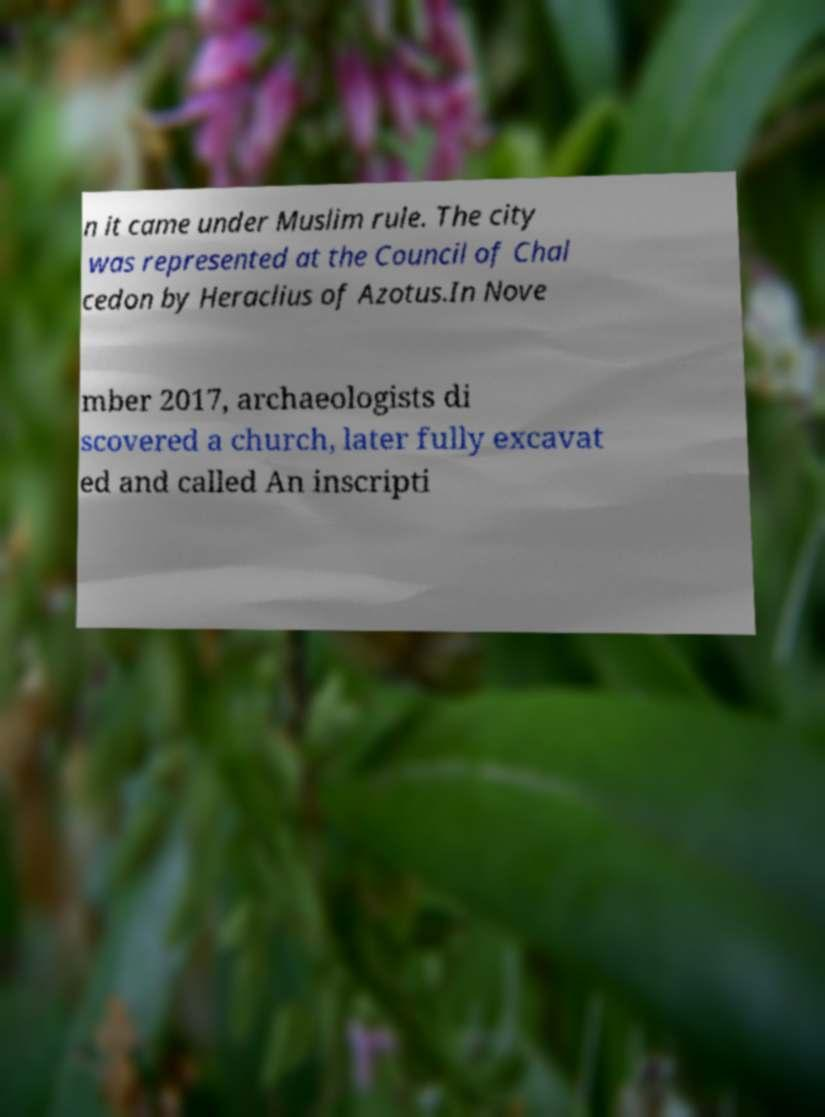Please identify and transcribe the text found in this image. n it came under Muslim rule. The city was represented at the Council of Chal cedon by Heraclius of Azotus.In Nove mber 2017, archaeologists di scovered a church, later fully excavat ed and called An inscripti 